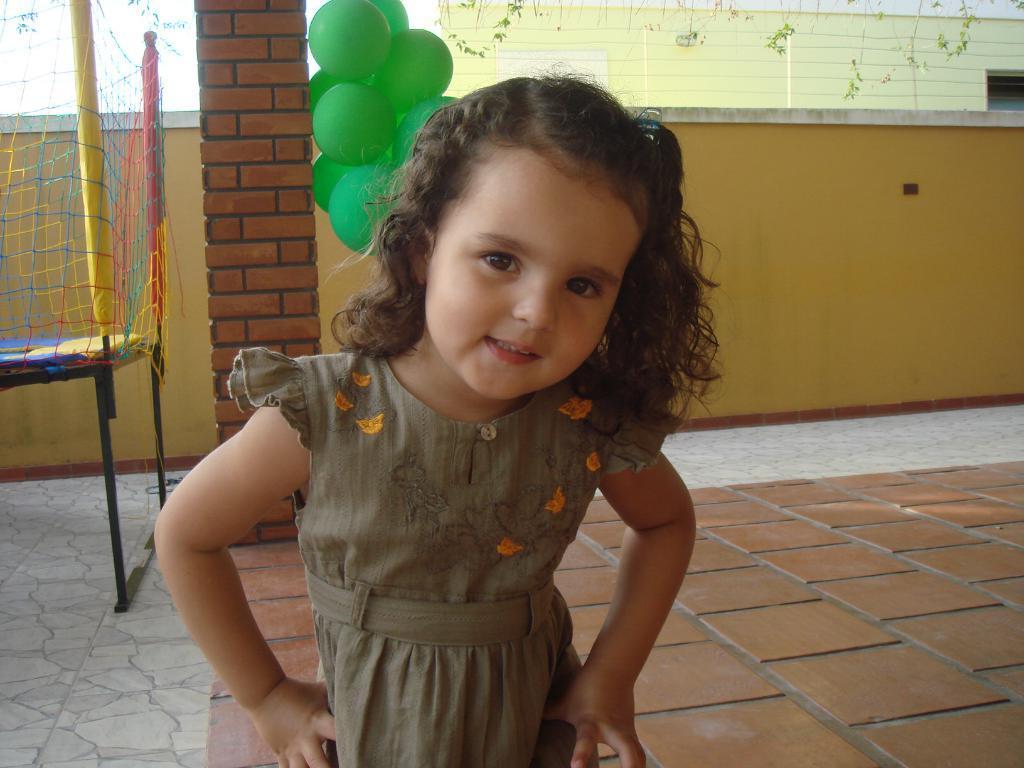Could you give a brief overview of what you see in this image? In this picture I can see a girl in front who is standing and in the middle of this image I see the floor and in the background I see the wall, green color balloons and the net on the left side of this image. 